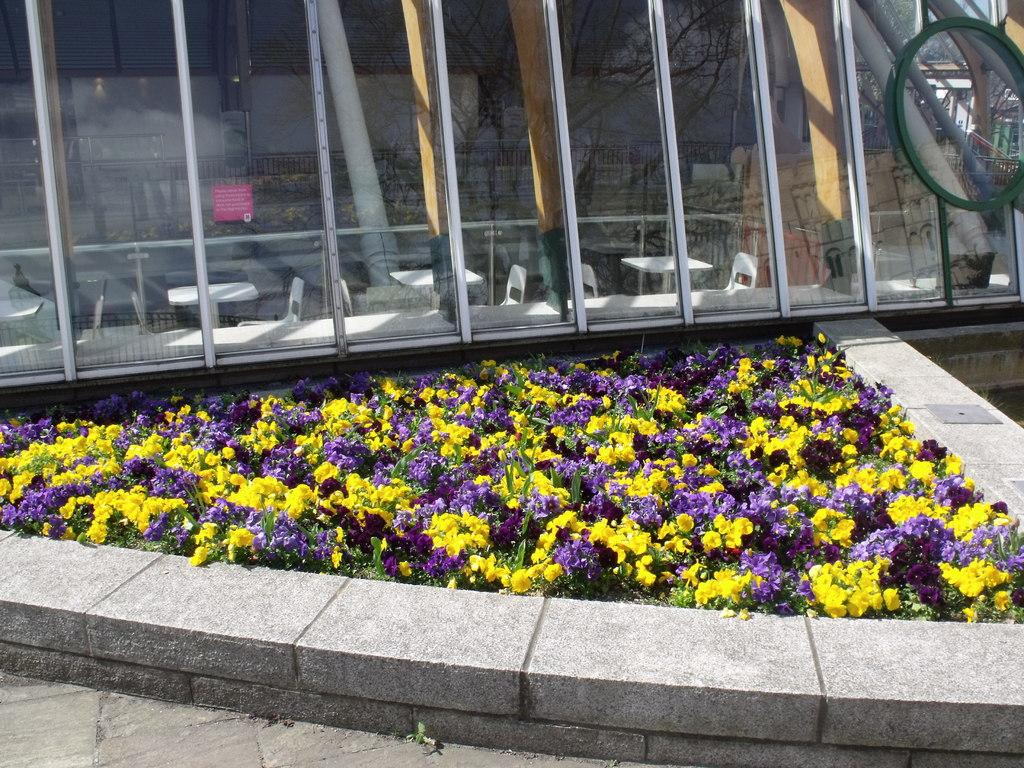What types of vegetation are at the bottom of the image? There are plants and flowers at the bottom of the image. What is behind the plants and flowers? There is a glass wall behind the plants and flowers. What can be seen through the glass wall? Chairs and tables are visible through the glass wall. How many potatoes are visible in the image? There are no potatoes present in the image. What type of egg can be seen on the table through the glass wall? There is no egg visible on the table through the glass wall in the image. 